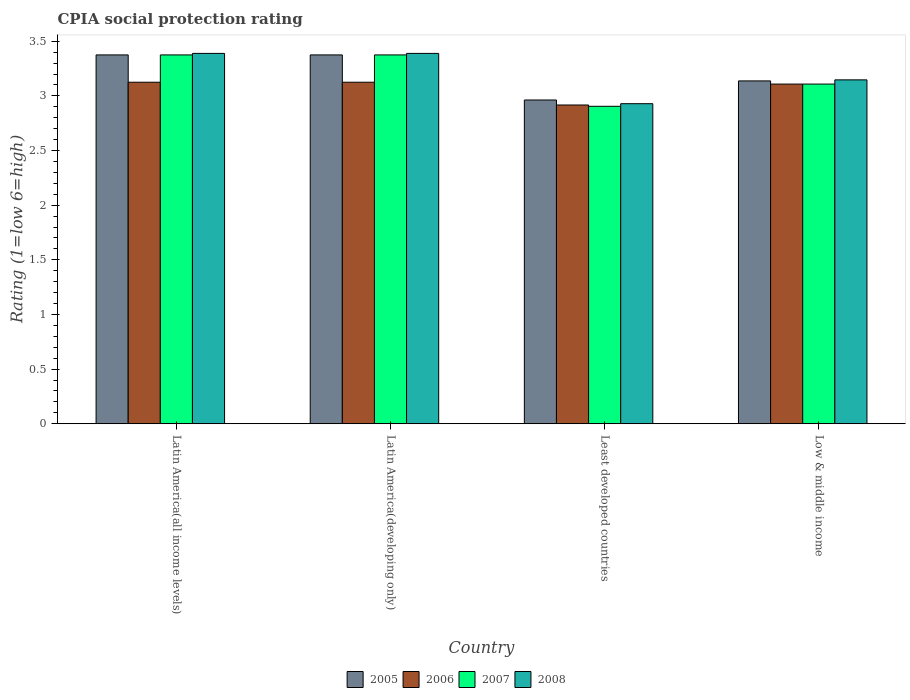How many different coloured bars are there?
Keep it short and to the point. 4. How many groups of bars are there?
Ensure brevity in your answer.  4. Are the number of bars on each tick of the X-axis equal?
Your response must be concise. Yes. How many bars are there on the 1st tick from the left?
Provide a succinct answer. 4. How many bars are there on the 2nd tick from the right?
Your answer should be compact. 4. What is the label of the 2nd group of bars from the left?
Your answer should be compact. Latin America(developing only). What is the CPIA rating in 2008 in Low & middle income?
Provide a succinct answer. 3.15. Across all countries, what is the maximum CPIA rating in 2005?
Ensure brevity in your answer.  3.38. Across all countries, what is the minimum CPIA rating in 2006?
Provide a short and direct response. 2.92. In which country was the CPIA rating in 2008 maximum?
Provide a succinct answer. Latin America(all income levels). In which country was the CPIA rating in 2006 minimum?
Your answer should be very brief. Least developed countries. What is the total CPIA rating in 2007 in the graph?
Ensure brevity in your answer.  12.76. What is the difference between the CPIA rating in 2005 in Latin America(developing only) and that in Least developed countries?
Offer a terse response. 0.41. What is the difference between the CPIA rating in 2008 in Latin America(all income levels) and the CPIA rating in 2005 in Low & middle income?
Offer a very short reply. 0.25. What is the average CPIA rating in 2005 per country?
Your answer should be very brief. 3.21. What is the difference between the CPIA rating of/in 2008 and CPIA rating of/in 2005 in Least developed countries?
Offer a very short reply. -0.03. In how many countries, is the CPIA rating in 2008 greater than 0.30000000000000004?
Ensure brevity in your answer.  4. What is the ratio of the CPIA rating in 2008 in Least developed countries to that in Low & middle income?
Make the answer very short. 0.93. Is the CPIA rating in 2005 in Latin America(developing only) less than that in Low & middle income?
Your response must be concise. No. What is the difference between the highest and the second highest CPIA rating in 2006?
Give a very brief answer. -0.02. What is the difference between the highest and the lowest CPIA rating in 2006?
Your answer should be very brief. 0.21. In how many countries, is the CPIA rating in 2006 greater than the average CPIA rating in 2006 taken over all countries?
Give a very brief answer. 3. Is the sum of the CPIA rating in 2007 in Latin America(all income levels) and Latin America(developing only) greater than the maximum CPIA rating in 2005 across all countries?
Provide a succinct answer. Yes. Is it the case that in every country, the sum of the CPIA rating in 2007 and CPIA rating in 2006 is greater than the CPIA rating in 2008?
Provide a short and direct response. Yes. Are all the bars in the graph horizontal?
Give a very brief answer. No. How many countries are there in the graph?
Your answer should be very brief. 4. Are the values on the major ticks of Y-axis written in scientific E-notation?
Keep it short and to the point. No. Does the graph contain any zero values?
Your response must be concise. No. Where does the legend appear in the graph?
Make the answer very short. Bottom center. What is the title of the graph?
Keep it short and to the point. CPIA social protection rating. What is the label or title of the X-axis?
Make the answer very short. Country. What is the Rating (1=low 6=high) of 2005 in Latin America(all income levels)?
Give a very brief answer. 3.38. What is the Rating (1=low 6=high) of 2006 in Latin America(all income levels)?
Ensure brevity in your answer.  3.12. What is the Rating (1=low 6=high) of 2007 in Latin America(all income levels)?
Offer a very short reply. 3.38. What is the Rating (1=low 6=high) of 2008 in Latin America(all income levels)?
Your answer should be compact. 3.39. What is the Rating (1=low 6=high) of 2005 in Latin America(developing only)?
Provide a succinct answer. 3.38. What is the Rating (1=low 6=high) in 2006 in Latin America(developing only)?
Ensure brevity in your answer.  3.12. What is the Rating (1=low 6=high) in 2007 in Latin America(developing only)?
Provide a succinct answer. 3.38. What is the Rating (1=low 6=high) of 2008 in Latin America(developing only)?
Offer a very short reply. 3.39. What is the Rating (1=low 6=high) in 2005 in Least developed countries?
Provide a succinct answer. 2.96. What is the Rating (1=low 6=high) in 2006 in Least developed countries?
Your answer should be compact. 2.92. What is the Rating (1=low 6=high) of 2007 in Least developed countries?
Your response must be concise. 2.9. What is the Rating (1=low 6=high) in 2008 in Least developed countries?
Offer a terse response. 2.93. What is the Rating (1=low 6=high) of 2005 in Low & middle income?
Give a very brief answer. 3.14. What is the Rating (1=low 6=high) in 2006 in Low & middle income?
Offer a terse response. 3.11. What is the Rating (1=low 6=high) in 2007 in Low & middle income?
Make the answer very short. 3.11. What is the Rating (1=low 6=high) of 2008 in Low & middle income?
Provide a succinct answer. 3.15. Across all countries, what is the maximum Rating (1=low 6=high) of 2005?
Your answer should be very brief. 3.38. Across all countries, what is the maximum Rating (1=low 6=high) in 2006?
Your response must be concise. 3.12. Across all countries, what is the maximum Rating (1=low 6=high) in 2007?
Make the answer very short. 3.38. Across all countries, what is the maximum Rating (1=low 6=high) of 2008?
Provide a succinct answer. 3.39. Across all countries, what is the minimum Rating (1=low 6=high) in 2005?
Give a very brief answer. 2.96. Across all countries, what is the minimum Rating (1=low 6=high) of 2006?
Your answer should be compact. 2.92. Across all countries, what is the minimum Rating (1=low 6=high) in 2007?
Keep it short and to the point. 2.9. Across all countries, what is the minimum Rating (1=low 6=high) in 2008?
Offer a very short reply. 2.93. What is the total Rating (1=low 6=high) in 2005 in the graph?
Offer a terse response. 12.85. What is the total Rating (1=low 6=high) of 2006 in the graph?
Offer a terse response. 12.27. What is the total Rating (1=low 6=high) of 2007 in the graph?
Your response must be concise. 12.76. What is the total Rating (1=low 6=high) of 2008 in the graph?
Provide a short and direct response. 12.85. What is the difference between the Rating (1=low 6=high) of 2006 in Latin America(all income levels) and that in Latin America(developing only)?
Provide a short and direct response. 0. What is the difference between the Rating (1=low 6=high) of 2007 in Latin America(all income levels) and that in Latin America(developing only)?
Provide a succinct answer. 0. What is the difference between the Rating (1=low 6=high) in 2005 in Latin America(all income levels) and that in Least developed countries?
Provide a short and direct response. 0.41. What is the difference between the Rating (1=low 6=high) in 2006 in Latin America(all income levels) and that in Least developed countries?
Give a very brief answer. 0.21. What is the difference between the Rating (1=low 6=high) of 2007 in Latin America(all income levels) and that in Least developed countries?
Provide a short and direct response. 0.47. What is the difference between the Rating (1=low 6=high) of 2008 in Latin America(all income levels) and that in Least developed countries?
Provide a succinct answer. 0.46. What is the difference between the Rating (1=low 6=high) of 2005 in Latin America(all income levels) and that in Low & middle income?
Your response must be concise. 0.24. What is the difference between the Rating (1=low 6=high) of 2006 in Latin America(all income levels) and that in Low & middle income?
Make the answer very short. 0.02. What is the difference between the Rating (1=low 6=high) in 2007 in Latin America(all income levels) and that in Low & middle income?
Keep it short and to the point. 0.27. What is the difference between the Rating (1=low 6=high) of 2008 in Latin America(all income levels) and that in Low & middle income?
Your response must be concise. 0.24. What is the difference between the Rating (1=low 6=high) in 2005 in Latin America(developing only) and that in Least developed countries?
Keep it short and to the point. 0.41. What is the difference between the Rating (1=low 6=high) in 2006 in Latin America(developing only) and that in Least developed countries?
Ensure brevity in your answer.  0.21. What is the difference between the Rating (1=low 6=high) in 2007 in Latin America(developing only) and that in Least developed countries?
Give a very brief answer. 0.47. What is the difference between the Rating (1=low 6=high) in 2008 in Latin America(developing only) and that in Least developed countries?
Your answer should be very brief. 0.46. What is the difference between the Rating (1=low 6=high) in 2005 in Latin America(developing only) and that in Low & middle income?
Give a very brief answer. 0.24. What is the difference between the Rating (1=low 6=high) in 2006 in Latin America(developing only) and that in Low & middle income?
Your answer should be compact. 0.02. What is the difference between the Rating (1=low 6=high) in 2007 in Latin America(developing only) and that in Low & middle income?
Your response must be concise. 0.27. What is the difference between the Rating (1=low 6=high) in 2008 in Latin America(developing only) and that in Low & middle income?
Offer a very short reply. 0.24. What is the difference between the Rating (1=low 6=high) of 2005 in Least developed countries and that in Low & middle income?
Offer a very short reply. -0.17. What is the difference between the Rating (1=low 6=high) in 2006 in Least developed countries and that in Low & middle income?
Make the answer very short. -0.19. What is the difference between the Rating (1=low 6=high) of 2007 in Least developed countries and that in Low & middle income?
Your response must be concise. -0.2. What is the difference between the Rating (1=low 6=high) of 2008 in Least developed countries and that in Low & middle income?
Give a very brief answer. -0.22. What is the difference between the Rating (1=low 6=high) of 2005 in Latin America(all income levels) and the Rating (1=low 6=high) of 2006 in Latin America(developing only)?
Give a very brief answer. 0.25. What is the difference between the Rating (1=low 6=high) of 2005 in Latin America(all income levels) and the Rating (1=low 6=high) of 2008 in Latin America(developing only)?
Your answer should be compact. -0.01. What is the difference between the Rating (1=low 6=high) in 2006 in Latin America(all income levels) and the Rating (1=low 6=high) in 2008 in Latin America(developing only)?
Give a very brief answer. -0.26. What is the difference between the Rating (1=low 6=high) in 2007 in Latin America(all income levels) and the Rating (1=low 6=high) in 2008 in Latin America(developing only)?
Make the answer very short. -0.01. What is the difference between the Rating (1=low 6=high) of 2005 in Latin America(all income levels) and the Rating (1=low 6=high) of 2006 in Least developed countries?
Your response must be concise. 0.46. What is the difference between the Rating (1=low 6=high) of 2005 in Latin America(all income levels) and the Rating (1=low 6=high) of 2007 in Least developed countries?
Your response must be concise. 0.47. What is the difference between the Rating (1=low 6=high) of 2005 in Latin America(all income levels) and the Rating (1=low 6=high) of 2008 in Least developed countries?
Provide a short and direct response. 0.45. What is the difference between the Rating (1=low 6=high) of 2006 in Latin America(all income levels) and the Rating (1=low 6=high) of 2007 in Least developed countries?
Provide a short and direct response. 0.22. What is the difference between the Rating (1=low 6=high) in 2006 in Latin America(all income levels) and the Rating (1=low 6=high) in 2008 in Least developed countries?
Offer a very short reply. 0.2. What is the difference between the Rating (1=low 6=high) of 2007 in Latin America(all income levels) and the Rating (1=low 6=high) of 2008 in Least developed countries?
Make the answer very short. 0.45. What is the difference between the Rating (1=low 6=high) of 2005 in Latin America(all income levels) and the Rating (1=low 6=high) of 2006 in Low & middle income?
Offer a very short reply. 0.27. What is the difference between the Rating (1=low 6=high) in 2005 in Latin America(all income levels) and the Rating (1=low 6=high) in 2007 in Low & middle income?
Offer a very short reply. 0.27. What is the difference between the Rating (1=low 6=high) of 2005 in Latin America(all income levels) and the Rating (1=low 6=high) of 2008 in Low & middle income?
Offer a terse response. 0.23. What is the difference between the Rating (1=low 6=high) of 2006 in Latin America(all income levels) and the Rating (1=low 6=high) of 2007 in Low & middle income?
Make the answer very short. 0.02. What is the difference between the Rating (1=low 6=high) of 2006 in Latin America(all income levels) and the Rating (1=low 6=high) of 2008 in Low & middle income?
Your response must be concise. -0.02. What is the difference between the Rating (1=low 6=high) in 2007 in Latin America(all income levels) and the Rating (1=low 6=high) in 2008 in Low & middle income?
Provide a succinct answer. 0.23. What is the difference between the Rating (1=low 6=high) of 2005 in Latin America(developing only) and the Rating (1=low 6=high) of 2006 in Least developed countries?
Provide a short and direct response. 0.46. What is the difference between the Rating (1=low 6=high) in 2005 in Latin America(developing only) and the Rating (1=low 6=high) in 2007 in Least developed countries?
Your answer should be very brief. 0.47. What is the difference between the Rating (1=low 6=high) in 2005 in Latin America(developing only) and the Rating (1=low 6=high) in 2008 in Least developed countries?
Make the answer very short. 0.45. What is the difference between the Rating (1=low 6=high) of 2006 in Latin America(developing only) and the Rating (1=low 6=high) of 2007 in Least developed countries?
Offer a very short reply. 0.22. What is the difference between the Rating (1=low 6=high) of 2006 in Latin America(developing only) and the Rating (1=low 6=high) of 2008 in Least developed countries?
Your answer should be very brief. 0.2. What is the difference between the Rating (1=low 6=high) of 2007 in Latin America(developing only) and the Rating (1=low 6=high) of 2008 in Least developed countries?
Ensure brevity in your answer.  0.45. What is the difference between the Rating (1=low 6=high) in 2005 in Latin America(developing only) and the Rating (1=low 6=high) in 2006 in Low & middle income?
Provide a succinct answer. 0.27. What is the difference between the Rating (1=low 6=high) of 2005 in Latin America(developing only) and the Rating (1=low 6=high) of 2007 in Low & middle income?
Provide a succinct answer. 0.27. What is the difference between the Rating (1=low 6=high) in 2005 in Latin America(developing only) and the Rating (1=low 6=high) in 2008 in Low & middle income?
Ensure brevity in your answer.  0.23. What is the difference between the Rating (1=low 6=high) of 2006 in Latin America(developing only) and the Rating (1=low 6=high) of 2007 in Low & middle income?
Provide a short and direct response. 0.02. What is the difference between the Rating (1=low 6=high) of 2006 in Latin America(developing only) and the Rating (1=low 6=high) of 2008 in Low & middle income?
Offer a very short reply. -0.02. What is the difference between the Rating (1=low 6=high) in 2007 in Latin America(developing only) and the Rating (1=low 6=high) in 2008 in Low & middle income?
Make the answer very short. 0.23. What is the difference between the Rating (1=low 6=high) in 2005 in Least developed countries and the Rating (1=low 6=high) in 2006 in Low & middle income?
Make the answer very short. -0.15. What is the difference between the Rating (1=low 6=high) of 2005 in Least developed countries and the Rating (1=low 6=high) of 2007 in Low & middle income?
Give a very brief answer. -0.15. What is the difference between the Rating (1=low 6=high) in 2005 in Least developed countries and the Rating (1=low 6=high) in 2008 in Low & middle income?
Your response must be concise. -0.18. What is the difference between the Rating (1=low 6=high) in 2006 in Least developed countries and the Rating (1=low 6=high) in 2007 in Low & middle income?
Provide a succinct answer. -0.19. What is the difference between the Rating (1=low 6=high) of 2006 in Least developed countries and the Rating (1=low 6=high) of 2008 in Low & middle income?
Your response must be concise. -0.23. What is the difference between the Rating (1=low 6=high) in 2007 in Least developed countries and the Rating (1=low 6=high) in 2008 in Low & middle income?
Provide a succinct answer. -0.24. What is the average Rating (1=low 6=high) of 2005 per country?
Provide a succinct answer. 3.21. What is the average Rating (1=low 6=high) of 2006 per country?
Your answer should be very brief. 3.07. What is the average Rating (1=low 6=high) of 2007 per country?
Your response must be concise. 3.19. What is the average Rating (1=low 6=high) of 2008 per country?
Your answer should be very brief. 3.21. What is the difference between the Rating (1=low 6=high) of 2005 and Rating (1=low 6=high) of 2007 in Latin America(all income levels)?
Offer a very short reply. 0. What is the difference between the Rating (1=low 6=high) of 2005 and Rating (1=low 6=high) of 2008 in Latin America(all income levels)?
Ensure brevity in your answer.  -0.01. What is the difference between the Rating (1=low 6=high) of 2006 and Rating (1=low 6=high) of 2008 in Latin America(all income levels)?
Your answer should be compact. -0.26. What is the difference between the Rating (1=low 6=high) in 2007 and Rating (1=low 6=high) in 2008 in Latin America(all income levels)?
Offer a very short reply. -0.01. What is the difference between the Rating (1=low 6=high) of 2005 and Rating (1=low 6=high) of 2007 in Latin America(developing only)?
Keep it short and to the point. 0. What is the difference between the Rating (1=low 6=high) in 2005 and Rating (1=low 6=high) in 2008 in Latin America(developing only)?
Provide a short and direct response. -0.01. What is the difference between the Rating (1=low 6=high) of 2006 and Rating (1=low 6=high) of 2007 in Latin America(developing only)?
Provide a short and direct response. -0.25. What is the difference between the Rating (1=low 6=high) of 2006 and Rating (1=low 6=high) of 2008 in Latin America(developing only)?
Offer a very short reply. -0.26. What is the difference between the Rating (1=low 6=high) in 2007 and Rating (1=low 6=high) in 2008 in Latin America(developing only)?
Make the answer very short. -0.01. What is the difference between the Rating (1=low 6=high) in 2005 and Rating (1=low 6=high) in 2006 in Least developed countries?
Offer a terse response. 0.05. What is the difference between the Rating (1=low 6=high) in 2005 and Rating (1=low 6=high) in 2007 in Least developed countries?
Offer a very short reply. 0.06. What is the difference between the Rating (1=low 6=high) in 2005 and Rating (1=low 6=high) in 2008 in Least developed countries?
Your answer should be compact. 0.03. What is the difference between the Rating (1=low 6=high) of 2006 and Rating (1=low 6=high) of 2007 in Least developed countries?
Offer a terse response. 0.01. What is the difference between the Rating (1=low 6=high) of 2006 and Rating (1=low 6=high) of 2008 in Least developed countries?
Ensure brevity in your answer.  -0.01. What is the difference between the Rating (1=low 6=high) in 2007 and Rating (1=low 6=high) in 2008 in Least developed countries?
Offer a terse response. -0.02. What is the difference between the Rating (1=low 6=high) of 2005 and Rating (1=low 6=high) of 2006 in Low & middle income?
Make the answer very short. 0.03. What is the difference between the Rating (1=low 6=high) of 2005 and Rating (1=low 6=high) of 2007 in Low & middle income?
Offer a very short reply. 0.03. What is the difference between the Rating (1=low 6=high) in 2005 and Rating (1=low 6=high) in 2008 in Low & middle income?
Provide a short and direct response. -0.01. What is the difference between the Rating (1=low 6=high) in 2006 and Rating (1=low 6=high) in 2007 in Low & middle income?
Offer a very short reply. 0. What is the difference between the Rating (1=low 6=high) of 2006 and Rating (1=low 6=high) of 2008 in Low & middle income?
Keep it short and to the point. -0.04. What is the difference between the Rating (1=low 6=high) in 2007 and Rating (1=low 6=high) in 2008 in Low & middle income?
Ensure brevity in your answer.  -0.04. What is the ratio of the Rating (1=low 6=high) of 2005 in Latin America(all income levels) to that in Latin America(developing only)?
Give a very brief answer. 1. What is the ratio of the Rating (1=low 6=high) of 2006 in Latin America(all income levels) to that in Latin America(developing only)?
Give a very brief answer. 1. What is the ratio of the Rating (1=low 6=high) of 2007 in Latin America(all income levels) to that in Latin America(developing only)?
Offer a terse response. 1. What is the ratio of the Rating (1=low 6=high) of 2005 in Latin America(all income levels) to that in Least developed countries?
Your answer should be compact. 1.14. What is the ratio of the Rating (1=low 6=high) in 2006 in Latin America(all income levels) to that in Least developed countries?
Offer a very short reply. 1.07. What is the ratio of the Rating (1=low 6=high) in 2007 in Latin America(all income levels) to that in Least developed countries?
Offer a terse response. 1.16. What is the ratio of the Rating (1=low 6=high) of 2008 in Latin America(all income levels) to that in Least developed countries?
Give a very brief answer. 1.16. What is the ratio of the Rating (1=low 6=high) of 2005 in Latin America(all income levels) to that in Low & middle income?
Ensure brevity in your answer.  1.08. What is the ratio of the Rating (1=low 6=high) of 2006 in Latin America(all income levels) to that in Low & middle income?
Your answer should be very brief. 1.01. What is the ratio of the Rating (1=low 6=high) in 2007 in Latin America(all income levels) to that in Low & middle income?
Your answer should be very brief. 1.09. What is the ratio of the Rating (1=low 6=high) in 2008 in Latin America(all income levels) to that in Low & middle income?
Your response must be concise. 1.08. What is the ratio of the Rating (1=low 6=high) of 2005 in Latin America(developing only) to that in Least developed countries?
Keep it short and to the point. 1.14. What is the ratio of the Rating (1=low 6=high) in 2006 in Latin America(developing only) to that in Least developed countries?
Your response must be concise. 1.07. What is the ratio of the Rating (1=low 6=high) of 2007 in Latin America(developing only) to that in Least developed countries?
Make the answer very short. 1.16. What is the ratio of the Rating (1=low 6=high) in 2008 in Latin America(developing only) to that in Least developed countries?
Provide a short and direct response. 1.16. What is the ratio of the Rating (1=low 6=high) of 2005 in Latin America(developing only) to that in Low & middle income?
Provide a short and direct response. 1.08. What is the ratio of the Rating (1=low 6=high) of 2006 in Latin America(developing only) to that in Low & middle income?
Your answer should be very brief. 1.01. What is the ratio of the Rating (1=low 6=high) of 2007 in Latin America(developing only) to that in Low & middle income?
Your answer should be very brief. 1.09. What is the ratio of the Rating (1=low 6=high) of 2008 in Latin America(developing only) to that in Low & middle income?
Your answer should be compact. 1.08. What is the ratio of the Rating (1=low 6=high) of 2005 in Least developed countries to that in Low & middle income?
Provide a succinct answer. 0.94. What is the ratio of the Rating (1=low 6=high) of 2006 in Least developed countries to that in Low & middle income?
Ensure brevity in your answer.  0.94. What is the ratio of the Rating (1=low 6=high) in 2007 in Least developed countries to that in Low & middle income?
Your response must be concise. 0.93. What is the ratio of the Rating (1=low 6=high) in 2008 in Least developed countries to that in Low & middle income?
Make the answer very short. 0.93. What is the difference between the highest and the second highest Rating (1=low 6=high) of 2007?
Offer a very short reply. 0. What is the difference between the highest and the lowest Rating (1=low 6=high) of 2005?
Offer a terse response. 0.41. What is the difference between the highest and the lowest Rating (1=low 6=high) of 2006?
Ensure brevity in your answer.  0.21. What is the difference between the highest and the lowest Rating (1=low 6=high) of 2007?
Offer a very short reply. 0.47. What is the difference between the highest and the lowest Rating (1=low 6=high) in 2008?
Keep it short and to the point. 0.46. 